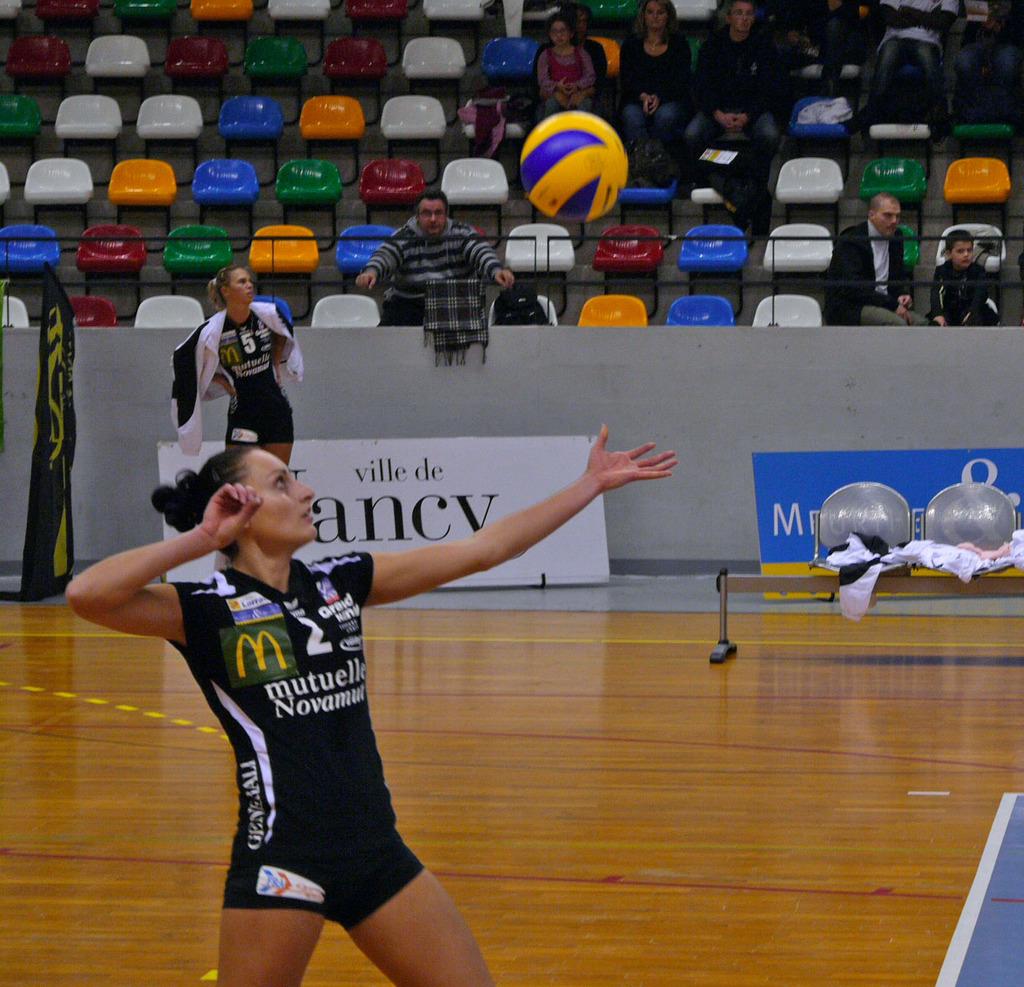What team does this person play for?
Give a very brief answer. Mutuelle novamut. What logo is in yellow and green on this shirt?
Provide a short and direct response. Mcdonald's. 